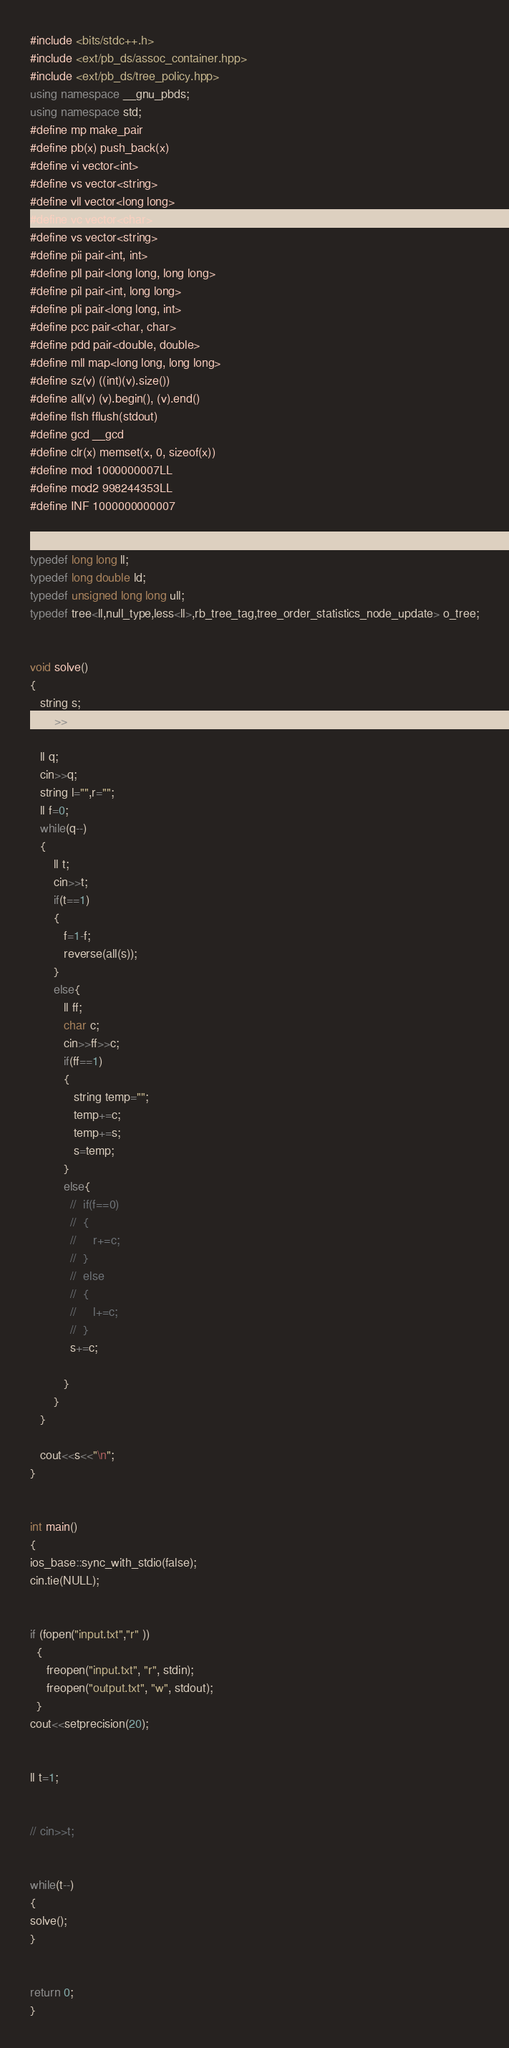Convert code to text. <code><loc_0><loc_0><loc_500><loc_500><_C++_>#include <bits/stdc++.h>
#include <ext/pb_ds/assoc_container.hpp>
#include <ext/pb_ds/tree_policy.hpp>
using namespace __gnu_pbds;
using namespace std;
#define mp make_pair
#define pb(x) push_back(x)
#define vi vector<int>
#define vs vector<string>
#define vll vector<long long>
#define vc vector<char>
#define vs vector<string>
#define pii pair<int, int>
#define pll pair<long long, long long>
#define pil pair<int, long long>
#define pli pair<long long, int>
#define pcc pair<char, char>
#define pdd pair<double, double>
#define mll map<long long, long long>
#define sz(v) ((int)(v).size())
#define all(v) (v).begin(), (v).end()
#define flsh fflush(stdout)
#define gcd __gcd
#define clr(x) memset(x, 0, sizeof(x))
#define mod 1000000007LL
#define mod2 998244353LL
#define INF 1000000000007
 

typedef long long ll;
typedef long double ld;
typedef unsigned long long ull;
typedef tree<ll,null_type,less<ll>,rb_tree_tag,tree_order_statistics_node_update> o_tree;


void solve()
{
   string s;
   cin>>s;

   ll q;
   cin>>q;
   string l="",r="";
   ll f=0;
   while(q--)
   {
       ll t;
       cin>>t;
       if(t==1)
       {
          f=1-f;
          reverse(all(s));
       } 
       else{
          ll ff;
          char c;
          cin>>ff>>c;
          if(ff==1)
          {
             string temp="";
             temp+=c;
             temp+=s;
             s=temp;
          }
          else{
            //  if(f==0)
            //  {
            //     r+=c;
            //  }
            //  else
            //  {
            //     l+=c;  
            //  }
            s+=c;
             
          }
       }
   }

   cout<<s<<"\n";
}


int main()
{
ios_base::sync_with_stdio(false);
cin.tie(NULL);


if (fopen("input.txt","r" ))
  {
     freopen("input.txt", "r", stdin);
     freopen("output.txt", "w", stdout);
  }
cout<<setprecision(20);


ll t=1;


// cin>>t;


while(t--)
{
solve();
} 


return 0;
}</code> 